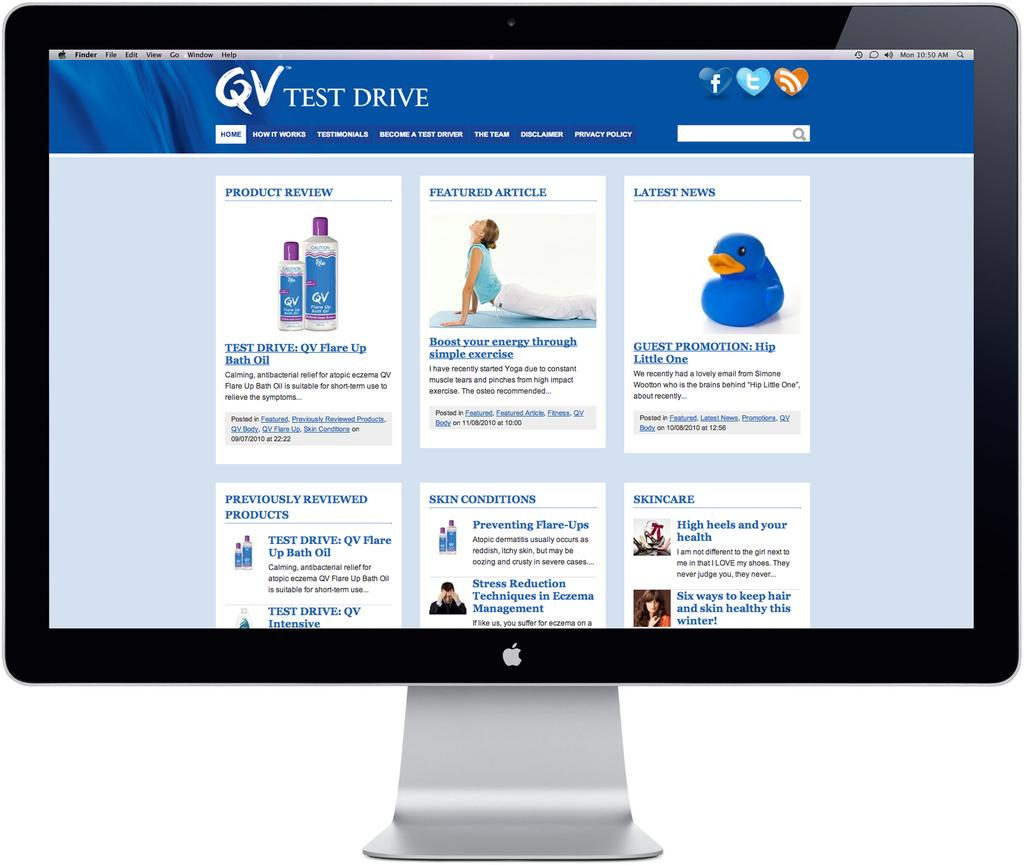<image>
Render a clear and concise summary of the photo. A pc monitor is open to a webpage for "QV Test Drive" 